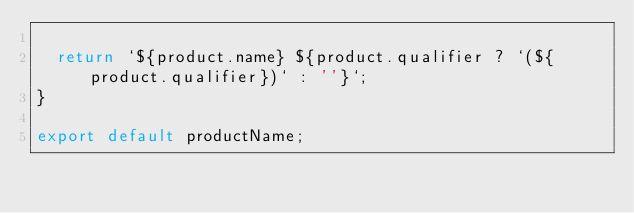<code> <loc_0><loc_0><loc_500><loc_500><_JavaScript_>
  return `${product.name} ${product.qualifier ? `(${product.qualifier})` : ''}`;
}

export default productName;
</code> 